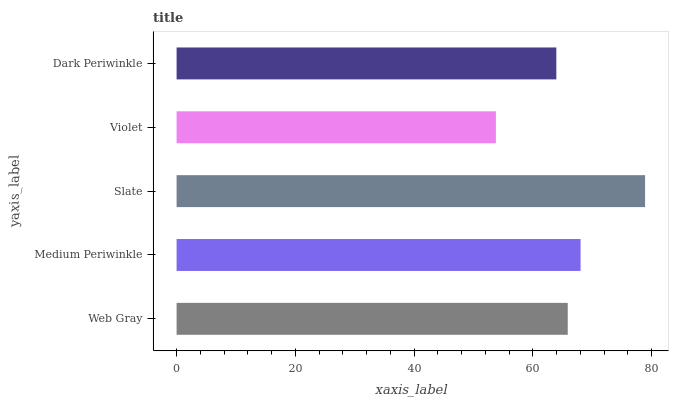Is Violet the minimum?
Answer yes or no. Yes. Is Slate the maximum?
Answer yes or no. Yes. Is Medium Periwinkle the minimum?
Answer yes or no. No. Is Medium Periwinkle the maximum?
Answer yes or no. No. Is Medium Periwinkle greater than Web Gray?
Answer yes or no. Yes. Is Web Gray less than Medium Periwinkle?
Answer yes or no. Yes. Is Web Gray greater than Medium Periwinkle?
Answer yes or no. No. Is Medium Periwinkle less than Web Gray?
Answer yes or no. No. Is Web Gray the high median?
Answer yes or no. Yes. Is Web Gray the low median?
Answer yes or no. Yes. Is Dark Periwinkle the high median?
Answer yes or no. No. Is Slate the low median?
Answer yes or no. No. 